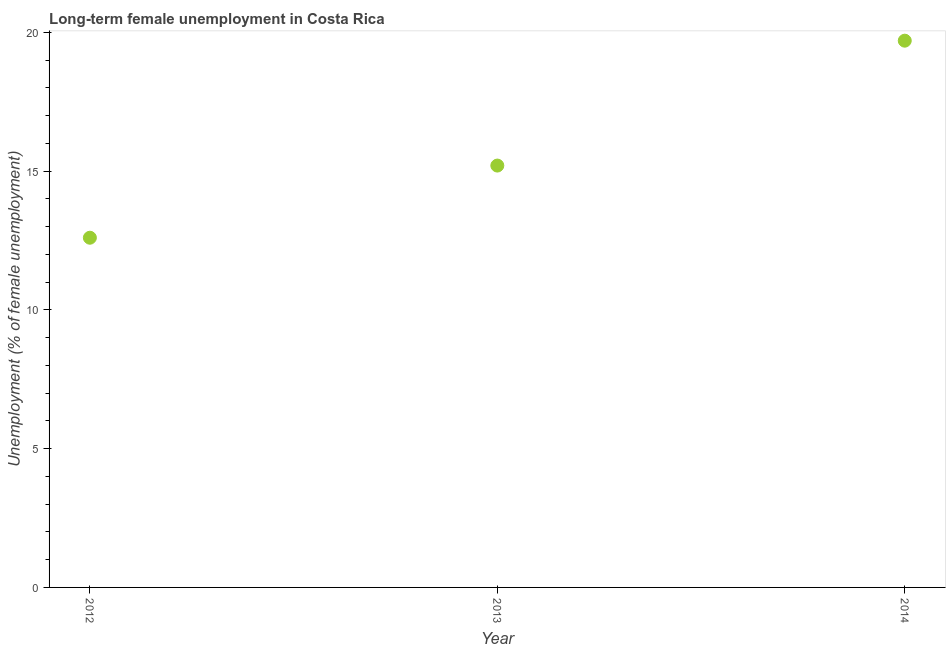What is the long-term female unemployment in 2014?
Offer a terse response. 19.7. Across all years, what is the maximum long-term female unemployment?
Give a very brief answer. 19.7. Across all years, what is the minimum long-term female unemployment?
Provide a succinct answer. 12.6. In which year was the long-term female unemployment maximum?
Give a very brief answer. 2014. In which year was the long-term female unemployment minimum?
Provide a short and direct response. 2012. What is the sum of the long-term female unemployment?
Your response must be concise. 47.5. What is the difference between the long-term female unemployment in 2012 and 2013?
Offer a terse response. -2.6. What is the average long-term female unemployment per year?
Provide a succinct answer. 15.83. What is the median long-term female unemployment?
Provide a short and direct response. 15.2. What is the ratio of the long-term female unemployment in 2013 to that in 2014?
Keep it short and to the point. 0.77. What is the difference between the highest and the second highest long-term female unemployment?
Offer a terse response. 4.5. Is the sum of the long-term female unemployment in 2013 and 2014 greater than the maximum long-term female unemployment across all years?
Make the answer very short. Yes. What is the difference between the highest and the lowest long-term female unemployment?
Keep it short and to the point. 7.1. Does the long-term female unemployment monotonically increase over the years?
Offer a very short reply. Yes. How many dotlines are there?
Your answer should be very brief. 1. Does the graph contain grids?
Provide a short and direct response. No. What is the title of the graph?
Offer a very short reply. Long-term female unemployment in Costa Rica. What is the label or title of the Y-axis?
Your response must be concise. Unemployment (% of female unemployment). What is the Unemployment (% of female unemployment) in 2012?
Your response must be concise. 12.6. What is the Unemployment (% of female unemployment) in 2013?
Your response must be concise. 15.2. What is the Unemployment (% of female unemployment) in 2014?
Offer a terse response. 19.7. What is the difference between the Unemployment (% of female unemployment) in 2012 and 2013?
Your response must be concise. -2.6. What is the difference between the Unemployment (% of female unemployment) in 2012 and 2014?
Ensure brevity in your answer.  -7.1. What is the ratio of the Unemployment (% of female unemployment) in 2012 to that in 2013?
Your answer should be compact. 0.83. What is the ratio of the Unemployment (% of female unemployment) in 2012 to that in 2014?
Give a very brief answer. 0.64. What is the ratio of the Unemployment (% of female unemployment) in 2013 to that in 2014?
Your response must be concise. 0.77. 